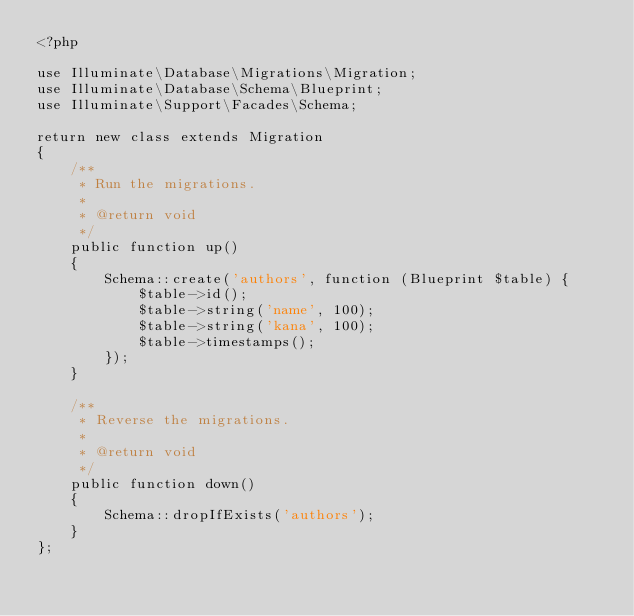Convert code to text. <code><loc_0><loc_0><loc_500><loc_500><_PHP_><?php

use Illuminate\Database\Migrations\Migration;
use Illuminate\Database\Schema\Blueprint;
use Illuminate\Support\Facades\Schema;

return new class extends Migration
{
    /**
     * Run the migrations.
     *
     * @return void
     */
    public function up()
    {
        Schema::create('authors', function (Blueprint $table) {
            $table->id();
            $table->string('name', 100);
            $table->string('kana', 100);
            $table->timestamps();
        });
    }

    /**
     * Reverse the migrations.
     *
     * @return void
     */
    public function down()
    {
        Schema::dropIfExists('authors');
    }
};
</code> 